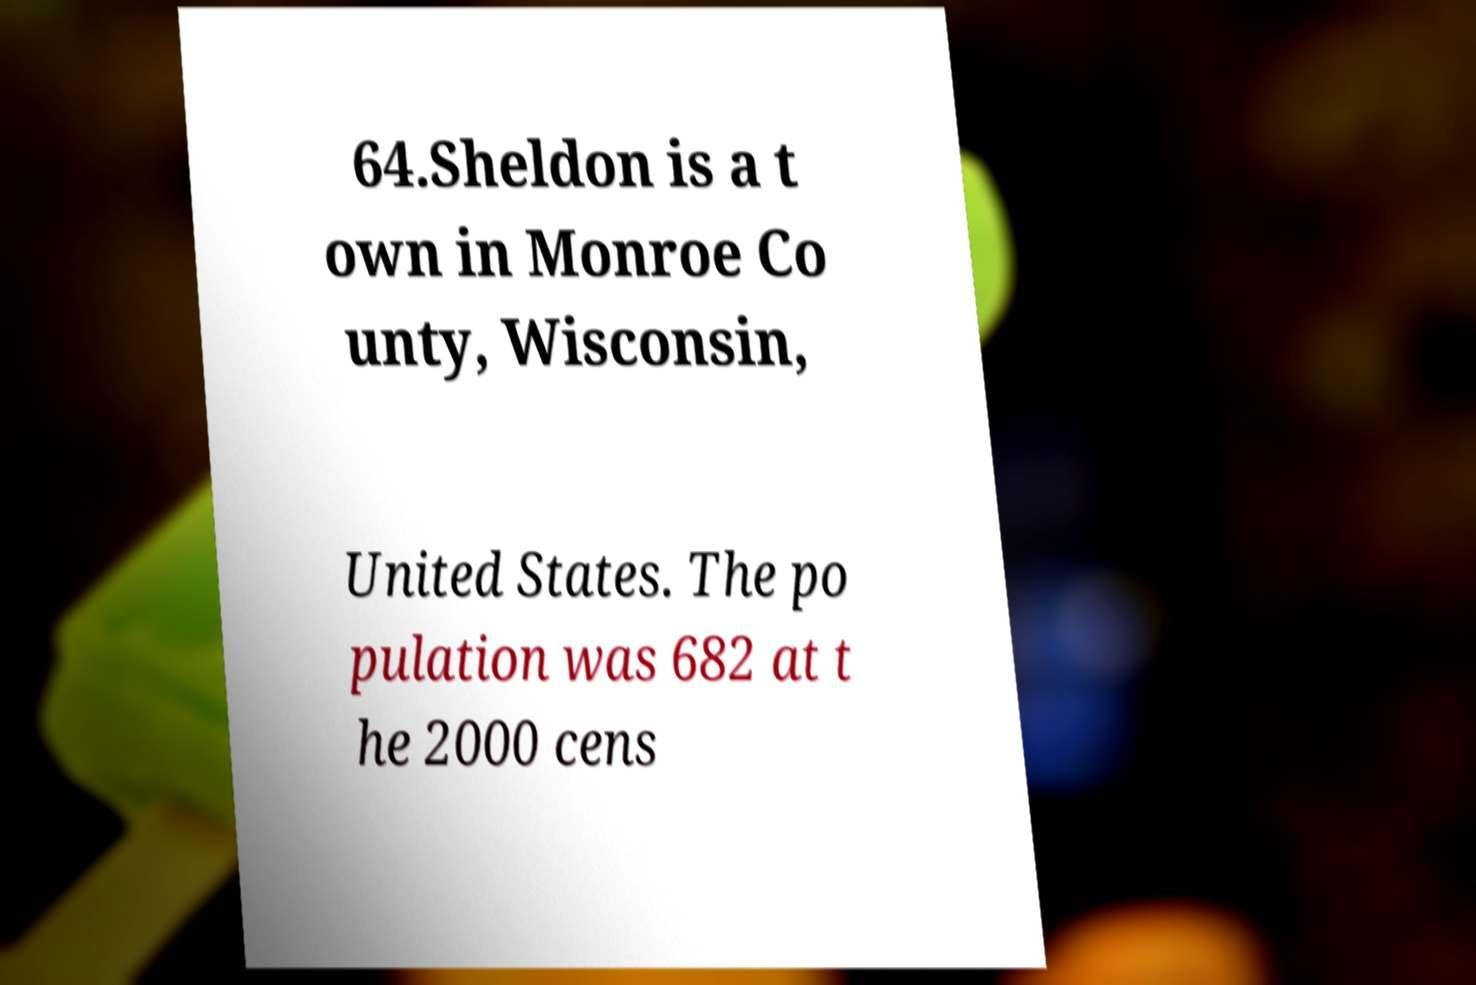What messages or text are displayed in this image? I need them in a readable, typed format. 64.Sheldon is a t own in Monroe Co unty, Wisconsin, United States. The po pulation was 682 at t he 2000 cens 